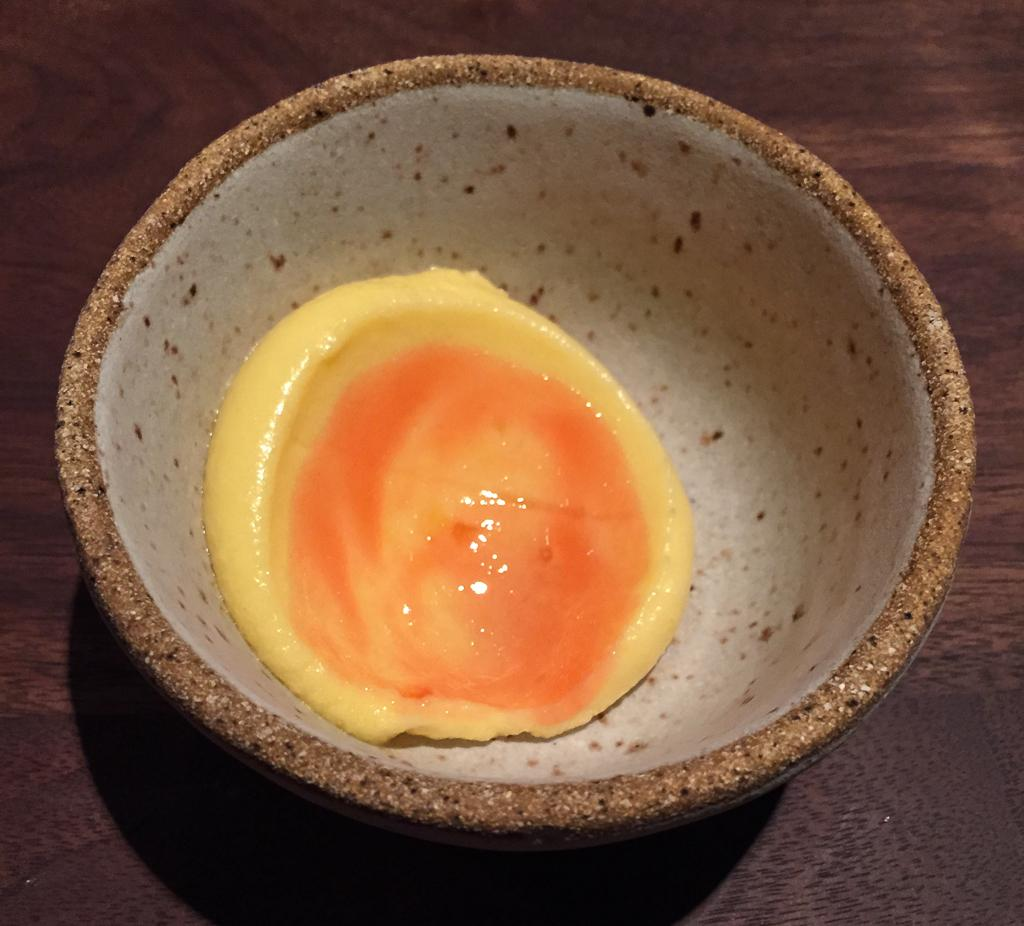What is in the bowl that is visible in the image? There is a bowl with food items in the image. What type of lipstick can be seen on the note in the image? There is no lipstick or note present in the image; it only features a bowl with food items. 